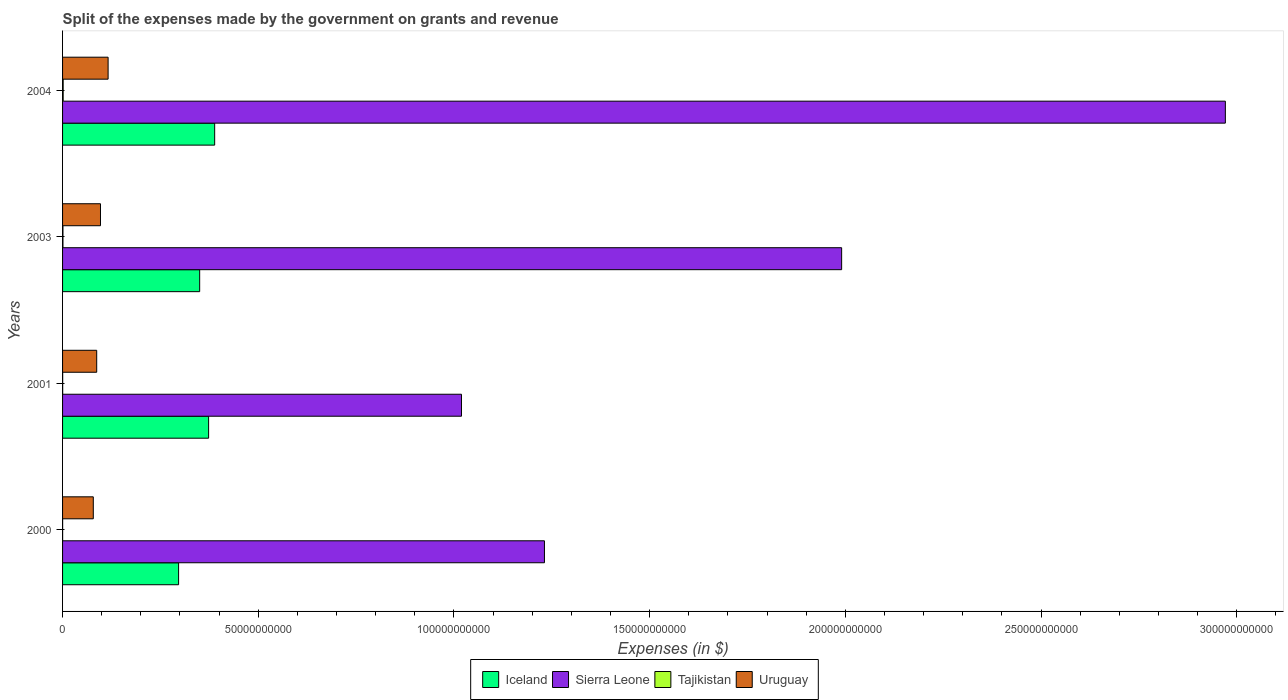How many groups of bars are there?
Offer a very short reply. 4. Are the number of bars per tick equal to the number of legend labels?
Make the answer very short. Yes. Are the number of bars on each tick of the Y-axis equal?
Provide a short and direct response. Yes. What is the label of the 4th group of bars from the top?
Offer a terse response. 2000. What is the expenses made by the government on grants and revenue in Sierra Leone in 2004?
Your response must be concise. 2.97e+11. Across all years, what is the maximum expenses made by the government on grants and revenue in Iceland?
Your answer should be compact. 3.89e+1. Across all years, what is the minimum expenses made by the government on grants and revenue in Sierra Leone?
Offer a very short reply. 1.02e+11. In which year was the expenses made by the government on grants and revenue in Iceland maximum?
Keep it short and to the point. 2004. In which year was the expenses made by the government on grants and revenue in Sierra Leone minimum?
Give a very brief answer. 2001. What is the total expenses made by the government on grants and revenue in Tajikistan in the graph?
Give a very brief answer. 2.95e+08. What is the difference between the expenses made by the government on grants and revenue in Uruguay in 2000 and that in 2001?
Your response must be concise. -8.68e+08. What is the difference between the expenses made by the government on grants and revenue in Tajikistan in 2001 and the expenses made by the government on grants and revenue in Iceland in 2003?
Offer a terse response. -3.50e+1. What is the average expenses made by the government on grants and revenue in Uruguay per year?
Keep it short and to the point. 9.47e+09. In the year 2003, what is the difference between the expenses made by the government on grants and revenue in Iceland and expenses made by the government on grants and revenue in Uruguay?
Make the answer very short. 2.53e+1. What is the ratio of the expenses made by the government on grants and revenue in Tajikistan in 2000 to that in 2001?
Make the answer very short. 0.56. Is the expenses made by the government on grants and revenue in Sierra Leone in 2003 less than that in 2004?
Your answer should be compact. Yes. Is the difference between the expenses made by the government on grants and revenue in Iceland in 2000 and 2004 greater than the difference between the expenses made by the government on grants and revenue in Uruguay in 2000 and 2004?
Provide a short and direct response. No. What is the difference between the highest and the second highest expenses made by the government on grants and revenue in Uruguay?
Offer a terse response. 1.95e+09. What is the difference between the highest and the lowest expenses made by the government on grants and revenue in Tajikistan?
Your answer should be very brief. 1.42e+08. In how many years, is the expenses made by the government on grants and revenue in Iceland greater than the average expenses made by the government on grants and revenue in Iceland taken over all years?
Offer a terse response. 2. Is the sum of the expenses made by the government on grants and revenue in Uruguay in 2001 and 2004 greater than the maximum expenses made by the government on grants and revenue in Sierra Leone across all years?
Ensure brevity in your answer.  No. What does the 3rd bar from the top in 2003 represents?
Make the answer very short. Sierra Leone. What does the 2nd bar from the bottom in 2001 represents?
Provide a short and direct response. Sierra Leone. Is it the case that in every year, the sum of the expenses made by the government on grants and revenue in Iceland and expenses made by the government on grants and revenue in Sierra Leone is greater than the expenses made by the government on grants and revenue in Uruguay?
Your answer should be compact. Yes. Are all the bars in the graph horizontal?
Provide a succinct answer. Yes. How many years are there in the graph?
Give a very brief answer. 4. Where does the legend appear in the graph?
Your answer should be compact. Bottom center. How many legend labels are there?
Offer a very short reply. 4. How are the legend labels stacked?
Provide a succinct answer. Horizontal. What is the title of the graph?
Offer a very short reply. Split of the expenses made by the government on grants and revenue. What is the label or title of the X-axis?
Your answer should be compact. Expenses (in $). What is the Expenses (in $) in Iceland in 2000?
Ensure brevity in your answer.  2.96e+1. What is the Expenses (in $) in Sierra Leone in 2000?
Provide a short and direct response. 1.23e+11. What is the Expenses (in $) in Tajikistan in 2000?
Provide a short and direct response. 1.41e+07. What is the Expenses (in $) of Uruguay in 2000?
Provide a short and direct response. 7.85e+09. What is the Expenses (in $) of Iceland in 2001?
Give a very brief answer. 3.73e+1. What is the Expenses (in $) in Sierra Leone in 2001?
Offer a very short reply. 1.02e+11. What is the Expenses (in $) of Tajikistan in 2001?
Your answer should be compact. 2.53e+07. What is the Expenses (in $) in Uruguay in 2001?
Give a very brief answer. 8.72e+09. What is the Expenses (in $) of Iceland in 2003?
Give a very brief answer. 3.50e+1. What is the Expenses (in $) of Sierra Leone in 2003?
Your answer should be very brief. 1.99e+11. What is the Expenses (in $) in Tajikistan in 2003?
Give a very brief answer. 9.93e+07. What is the Expenses (in $) in Uruguay in 2003?
Your answer should be compact. 9.69e+09. What is the Expenses (in $) of Iceland in 2004?
Offer a terse response. 3.89e+1. What is the Expenses (in $) in Sierra Leone in 2004?
Provide a short and direct response. 2.97e+11. What is the Expenses (in $) in Tajikistan in 2004?
Give a very brief answer. 1.56e+08. What is the Expenses (in $) in Uruguay in 2004?
Keep it short and to the point. 1.16e+1. Across all years, what is the maximum Expenses (in $) of Iceland?
Offer a terse response. 3.89e+1. Across all years, what is the maximum Expenses (in $) in Sierra Leone?
Give a very brief answer. 2.97e+11. Across all years, what is the maximum Expenses (in $) in Tajikistan?
Provide a succinct answer. 1.56e+08. Across all years, what is the maximum Expenses (in $) of Uruguay?
Provide a short and direct response. 1.16e+1. Across all years, what is the minimum Expenses (in $) of Iceland?
Give a very brief answer. 2.96e+1. Across all years, what is the minimum Expenses (in $) of Sierra Leone?
Provide a short and direct response. 1.02e+11. Across all years, what is the minimum Expenses (in $) of Tajikistan?
Your answer should be compact. 1.41e+07. Across all years, what is the minimum Expenses (in $) of Uruguay?
Ensure brevity in your answer.  7.85e+09. What is the total Expenses (in $) in Iceland in the graph?
Provide a succinct answer. 1.41e+11. What is the total Expenses (in $) of Sierra Leone in the graph?
Provide a short and direct response. 7.21e+11. What is the total Expenses (in $) of Tajikistan in the graph?
Provide a succinct answer. 2.95e+08. What is the total Expenses (in $) in Uruguay in the graph?
Ensure brevity in your answer.  3.79e+1. What is the difference between the Expenses (in $) of Iceland in 2000 and that in 2001?
Keep it short and to the point. -7.67e+09. What is the difference between the Expenses (in $) in Sierra Leone in 2000 and that in 2001?
Your response must be concise. 2.12e+1. What is the difference between the Expenses (in $) of Tajikistan in 2000 and that in 2001?
Your answer should be compact. -1.12e+07. What is the difference between the Expenses (in $) in Uruguay in 2000 and that in 2001?
Ensure brevity in your answer.  -8.68e+08. What is the difference between the Expenses (in $) in Iceland in 2000 and that in 2003?
Your answer should be compact. -5.38e+09. What is the difference between the Expenses (in $) of Sierra Leone in 2000 and that in 2003?
Keep it short and to the point. -7.59e+1. What is the difference between the Expenses (in $) of Tajikistan in 2000 and that in 2003?
Your response must be concise. -8.52e+07. What is the difference between the Expenses (in $) of Uruguay in 2000 and that in 2003?
Your answer should be very brief. -1.83e+09. What is the difference between the Expenses (in $) in Iceland in 2000 and that in 2004?
Your answer should be compact. -9.22e+09. What is the difference between the Expenses (in $) in Sierra Leone in 2000 and that in 2004?
Make the answer very short. -1.74e+11. What is the difference between the Expenses (in $) in Tajikistan in 2000 and that in 2004?
Provide a short and direct response. -1.42e+08. What is the difference between the Expenses (in $) of Uruguay in 2000 and that in 2004?
Provide a short and direct response. -3.78e+09. What is the difference between the Expenses (in $) of Iceland in 2001 and that in 2003?
Make the answer very short. 2.28e+09. What is the difference between the Expenses (in $) in Sierra Leone in 2001 and that in 2003?
Give a very brief answer. -9.71e+1. What is the difference between the Expenses (in $) of Tajikistan in 2001 and that in 2003?
Your response must be concise. -7.40e+07. What is the difference between the Expenses (in $) of Uruguay in 2001 and that in 2003?
Ensure brevity in your answer.  -9.65e+08. What is the difference between the Expenses (in $) of Iceland in 2001 and that in 2004?
Keep it short and to the point. -1.55e+09. What is the difference between the Expenses (in $) in Sierra Leone in 2001 and that in 2004?
Offer a terse response. -1.95e+11. What is the difference between the Expenses (in $) of Tajikistan in 2001 and that in 2004?
Give a very brief answer. -1.31e+08. What is the difference between the Expenses (in $) of Uruguay in 2001 and that in 2004?
Offer a terse response. -2.91e+09. What is the difference between the Expenses (in $) in Iceland in 2003 and that in 2004?
Offer a terse response. -3.83e+09. What is the difference between the Expenses (in $) of Sierra Leone in 2003 and that in 2004?
Make the answer very short. -9.80e+1. What is the difference between the Expenses (in $) in Tajikistan in 2003 and that in 2004?
Offer a terse response. -5.65e+07. What is the difference between the Expenses (in $) of Uruguay in 2003 and that in 2004?
Make the answer very short. -1.95e+09. What is the difference between the Expenses (in $) of Iceland in 2000 and the Expenses (in $) of Sierra Leone in 2001?
Keep it short and to the point. -7.23e+1. What is the difference between the Expenses (in $) in Iceland in 2000 and the Expenses (in $) in Tajikistan in 2001?
Offer a very short reply. 2.96e+1. What is the difference between the Expenses (in $) of Iceland in 2000 and the Expenses (in $) of Uruguay in 2001?
Make the answer very short. 2.09e+1. What is the difference between the Expenses (in $) of Sierra Leone in 2000 and the Expenses (in $) of Tajikistan in 2001?
Make the answer very short. 1.23e+11. What is the difference between the Expenses (in $) of Sierra Leone in 2000 and the Expenses (in $) of Uruguay in 2001?
Give a very brief answer. 1.14e+11. What is the difference between the Expenses (in $) in Tajikistan in 2000 and the Expenses (in $) in Uruguay in 2001?
Your answer should be very brief. -8.71e+09. What is the difference between the Expenses (in $) in Iceland in 2000 and the Expenses (in $) in Sierra Leone in 2003?
Offer a terse response. -1.69e+11. What is the difference between the Expenses (in $) of Iceland in 2000 and the Expenses (in $) of Tajikistan in 2003?
Provide a succinct answer. 2.95e+1. What is the difference between the Expenses (in $) in Iceland in 2000 and the Expenses (in $) in Uruguay in 2003?
Provide a succinct answer. 2.00e+1. What is the difference between the Expenses (in $) in Sierra Leone in 2000 and the Expenses (in $) in Tajikistan in 2003?
Make the answer very short. 1.23e+11. What is the difference between the Expenses (in $) in Sierra Leone in 2000 and the Expenses (in $) in Uruguay in 2003?
Your answer should be very brief. 1.13e+11. What is the difference between the Expenses (in $) in Tajikistan in 2000 and the Expenses (in $) in Uruguay in 2003?
Offer a very short reply. -9.67e+09. What is the difference between the Expenses (in $) in Iceland in 2000 and the Expenses (in $) in Sierra Leone in 2004?
Provide a short and direct response. -2.67e+11. What is the difference between the Expenses (in $) in Iceland in 2000 and the Expenses (in $) in Tajikistan in 2004?
Make the answer very short. 2.95e+1. What is the difference between the Expenses (in $) of Iceland in 2000 and the Expenses (in $) of Uruguay in 2004?
Ensure brevity in your answer.  1.80e+1. What is the difference between the Expenses (in $) in Sierra Leone in 2000 and the Expenses (in $) in Tajikistan in 2004?
Provide a succinct answer. 1.23e+11. What is the difference between the Expenses (in $) of Sierra Leone in 2000 and the Expenses (in $) of Uruguay in 2004?
Your answer should be very brief. 1.11e+11. What is the difference between the Expenses (in $) in Tajikistan in 2000 and the Expenses (in $) in Uruguay in 2004?
Your answer should be compact. -1.16e+1. What is the difference between the Expenses (in $) of Iceland in 2001 and the Expenses (in $) of Sierra Leone in 2003?
Offer a very short reply. -1.62e+11. What is the difference between the Expenses (in $) in Iceland in 2001 and the Expenses (in $) in Tajikistan in 2003?
Provide a succinct answer. 3.72e+1. What is the difference between the Expenses (in $) of Iceland in 2001 and the Expenses (in $) of Uruguay in 2003?
Your answer should be very brief. 2.76e+1. What is the difference between the Expenses (in $) of Sierra Leone in 2001 and the Expenses (in $) of Tajikistan in 2003?
Provide a succinct answer. 1.02e+11. What is the difference between the Expenses (in $) in Sierra Leone in 2001 and the Expenses (in $) in Uruguay in 2003?
Your answer should be compact. 9.22e+1. What is the difference between the Expenses (in $) in Tajikistan in 2001 and the Expenses (in $) in Uruguay in 2003?
Your response must be concise. -9.66e+09. What is the difference between the Expenses (in $) in Iceland in 2001 and the Expenses (in $) in Sierra Leone in 2004?
Give a very brief answer. -2.60e+11. What is the difference between the Expenses (in $) of Iceland in 2001 and the Expenses (in $) of Tajikistan in 2004?
Provide a short and direct response. 3.72e+1. What is the difference between the Expenses (in $) in Iceland in 2001 and the Expenses (in $) in Uruguay in 2004?
Offer a terse response. 2.57e+1. What is the difference between the Expenses (in $) in Sierra Leone in 2001 and the Expenses (in $) in Tajikistan in 2004?
Make the answer very short. 1.02e+11. What is the difference between the Expenses (in $) of Sierra Leone in 2001 and the Expenses (in $) of Uruguay in 2004?
Make the answer very short. 9.03e+1. What is the difference between the Expenses (in $) in Tajikistan in 2001 and the Expenses (in $) in Uruguay in 2004?
Provide a succinct answer. -1.16e+1. What is the difference between the Expenses (in $) of Iceland in 2003 and the Expenses (in $) of Sierra Leone in 2004?
Your response must be concise. -2.62e+11. What is the difference between the Expenses (in $) in Iceland in 2003 and the Expenses (in $) in Tajikistan in 2004?
Your answer should be compact. 3.49e+1. What is the difference between the Expenses (in $) in Iceland in 2003 and the Expenses (in $) in Uruguay in 2004?
Provide a succinct answer. 2.34e+1. What is the difference between the Expenses (in $) in Sierra Leone in 2003 and the Expenses (in $) in Tajikistan in 2004?
Your answer should be very brief. 1.99e+11. What is the difference between the Expenses (in $) of Sierra Leone in 2003 and the Expenses (in $) of Uruguay in 2004?
Your response must be concise. 1.87e+11. What is the difference between the Expenses (in $) of Tajikistan in 2003 and the Expenses (in $) of Uruguay in 2004?
Offer a terse response. -1.15e+1. What is the average Expenses (in $) in Iceland per year?
Give a very brief answer. 3.52e+1. What is the average Expenses (in $) of Sierra Leone per year?
Your answer should be compact. 1.80e+11. What is the average Expenses (in $) in Tajikistan per year?
Ensure brevity in your answer.  7.36e+07. What is the average Expenses (in $) in Uruguay per year?
Give a very brief answer. 9.47e+09. In the year 2000, what is the difference between the Expenses (in $) in Iceland and Expenses (in $) in Sierra Leone?
Offer a terse response. -9.35e+1. In the year 2000, what is the difference between the Expenses (in $) of Iceland and Expenses (in $) of Tajikistan?
Your answer should be compact. 2.96e+1. In the year 2000, what is the difference between the Expenses (in $) of Iceland and Expenses (in $) of Uruguay?
Keep it short and to the point. 2.18e+1. In the year 2000, what is the difference between the Expenses (in $) in Sierra Leone and Expenses (in $) in Tajikistan?
Provide a short and direct response. 1.23e+11. In the year 2000, what is the difference between the Expenses (in $) of Sierra Leone and Expenses (in $) of Uruguay?
Offer a terse response. 1.15e+11. In the year 2000, what is the difference between the Expenses (in $) in Tajikistan and Expenses (in $) in Uruguay?
Offer a terse response. -7.84e+09. In the year 2001, what is the difference between the Expenses (in $) in Iceland and Expenses (in $) in Sierra Leone?
Ensure brevity in your answer.  -6.46e+1. In the year 2001, what is the difference between the Expenses (in $) in Iceland and Expenses (in $) in Tajikistan?
Keep it short and to the point. 3.73e+1. In the year 2001, what is the difference between the Expenses (in $) in Iceland and Expenses (in $) in Uruguay?
Make the answer very short. 2.86e+1. In the year 2001, what is the difference between the Expenses (in $) of Sierra Leone and Expenses (in $) of Tajikistan?
Offer a terse response. 1.02e+11. In the year 2001, what is the difference between the Expenses (in $) of Sierra Leone and Expenses (in $) of Uruguay?
Ensure brevity in your answer.  9.32e+1. In the year 2001, what is the difference between the Expenses (in $) in Tajikistan and Expenses (in $) in Uruguay?
Offer a terse response. -8.70e+09. In the year 2003, what is the difference between the Expenses (in $) of Iceland and Expenses (in $) of Sierra Leone?
Offer a terse response. -1.64e+11. In the year 2003, what is the difference between the Expenses (in $) of Iceland and Expenses (in $) of Tajikistan?
Give a very brief answer. 3.49e+1. In the year 2003, what is the difference between the Expenses (in $) in Iceland and Expenses (in $) in Uruguay?
Give a very brief answer. 2.53e+1. In the year 2003, what is the difference between the Expenses (in $) of Sierra Leone and Expenses (in $) of Tajikistan?
Provide a short and direct response. 1.99e+11. In the year 2003, what is the difference between the Expenses (in $) in Sierra Leone and Expenses (in $) in Uruguay?
Keep it short and to the point. 1.89e+11. In the year 2003, what is the difference between the Expenses (in $) in Tajikistan and Expenses (in $) in Uruguay?
Ensure brevity in your answer.  -9.59e+09. In the year 2004, what is the difference between the Expenses (in $) in Iceland and Expenses (in $) in Sierra Leone?
Provide a short and direct response. -2.58e+11. In the year 2004, what is the difference between the Expenses (in $) of Iceland and Expenses (in $) of Tajikistan?
Give a very brief answer. 3.87e+1. In the year 2004, what is the difference between the Expenses (in $) in Iceland and Expenses (in $) in Uruguay?
Make the answer very short. 2.72e+1. In the year 2004, what is the difference between the Expenses (in $) of Sierra Leone and Expenses (in $) of Tajikistan?
Give a very brief answer. 2.97e+11. In the year 2004, what is the difference between the Expenses (in $) of Sierra Leone and Expenses (in $) of Uruguay?
Provide a short and direct response. 2.85e+11. In the year 2004, what is the difference between the Expenses (in $) in Tajikistan and Expenses (in $) in Uruguay?
Offer a very short reply. -1.15e+1. What is the ratio of the Expenses (in $) of Iceland in 2000 to that in 2001?
Your response must be concise. 0.79. What is the ratio of the Expenses (in $) of Sierra Leone in 2000 to that in 2001?
Make the answer very short. 1.21. What is the ratio of the Expenses (in $) of Tajikistan in 2000 to that in 2001?
Ensure brevity in your answer.  0.56. What is the ratio of the Expenses (in $) in Uruguay in 2000 to that in 2001?
Your answer should be very brief. 0.9. What is the ratio of the Expenses (in $) in Iceland in 2000 to that in 2003?
Provide a succinct answer. 0.85. What is the ratio of the Expenses (in $) of Sierra Leone in 2000 to that in 2003?
Offer a terse response. 0.62. What is the ratio of the Expenses (in $) in Tajikistan in 2000 to that in 2003?
Offer a terse response. 0.14. What is the ratio of the Expenses (in $) in Uruguay in 2000 to that in 2003?
Give a very brief answer. 0.81. What is the ratio of the Expenses (in $) of Iceland in 2000 to that in 2004?
Offer a very short reply. 0.76. What is the ratio of the Expenses (in $) of Sierra Leone in 2000 to that in 2004?
Provide a succinct answer. 0.41. What is the ratio of the Expenses (in $) of Tajikistan in 2000 to that in 2004?
Make the answer very short. 0.09. What is the ratio of the Expenses (in $) of Uruguay in 2000 to that in 2004?
Offer a terse response. 0.68. What is the ratio of the Expenses (in $) in Iceland in 2001 to that in 2003?
Give a very brief answer. 1.07. What is the ratio of the Expenses (in $) in Sierra Leone in 2001 to that in 2003?
Keep it short and to the point. 0.51. What is the ratio of the Expenses (in $) of Tajikistan in 2001 to that in 2003?
Your response must be concise. 0.25. What is the ratio of the Expenses (in $) in Uruguay in 2001 to that in 2003?
Offer a very short reply. 0.9. What is the ratio of the Expenses (in $) in Iceland in 2001 to that in 2004?
Keep it short and to the point. 0.96. What is the ratio of the Expenses (in $) of Sierra Leone in 2001 to that in 2004?
Offer a terse response. 0.34. What is the ratio of the Expenses (in $) in Tajikistan in 2001 to that in 2004?
Your answer should be compact. 0.16. What is the ratio of the Expenses (in $) of Uruguay in 2001 to that in 2004?
Give a very brief answer. 0.75. What is the ratio of the Expenses (in $) in Iceland in 2003 to that in 2004?
Offer a terse response. 0.9. What is the ratio of the Expenses (in $) in Sierra Leone in 2003 to that in 2004?
Provide a succinct answer. 0.67. What is the ratio of the Expenses (in $) in Tajikistan in 2003 to that in 2004?
Your response must be concise. 0.64. What is the ratio of the Expenses (in $) of Uruguay in 2003 to that in 2004?
Offer a very short reply. 0.83. What is the difference between the highest and the second highest Expenses (in $) in Iceland?
Your response must be concise. 1.55e+09. What is the difference between the highest and the second highest Expenses (in $) in Sierra Leone?
Offer a very short reply. 9.80e+1. What is the difference between the highest and the second highest Expenses (in $) of Tajikistan?
Your answer should be compact. 5.65e+07. What is the difference between the highest and the second highest Expenses (in $) of Uruguay?
Make the answer very short. 1.95e+09. What is the difference between the highest and the lowest Expenses (in $) of Iceland?
Keep it short and to the point. 9.22e+09. What is the difference between the highest and the lowest Expenses (in $) in Sierra Leone?
Your answer should be compact. 1.95e+11. What is the difference between the highest and the lowest Expenses (in $) of Tajikistan?
Provide a short and direct response. 1.42e+08. What is the difference between the highest and the lowest Expenses (in $) of Uruguay?
Your answer should be very brief. 3.78e+09. 